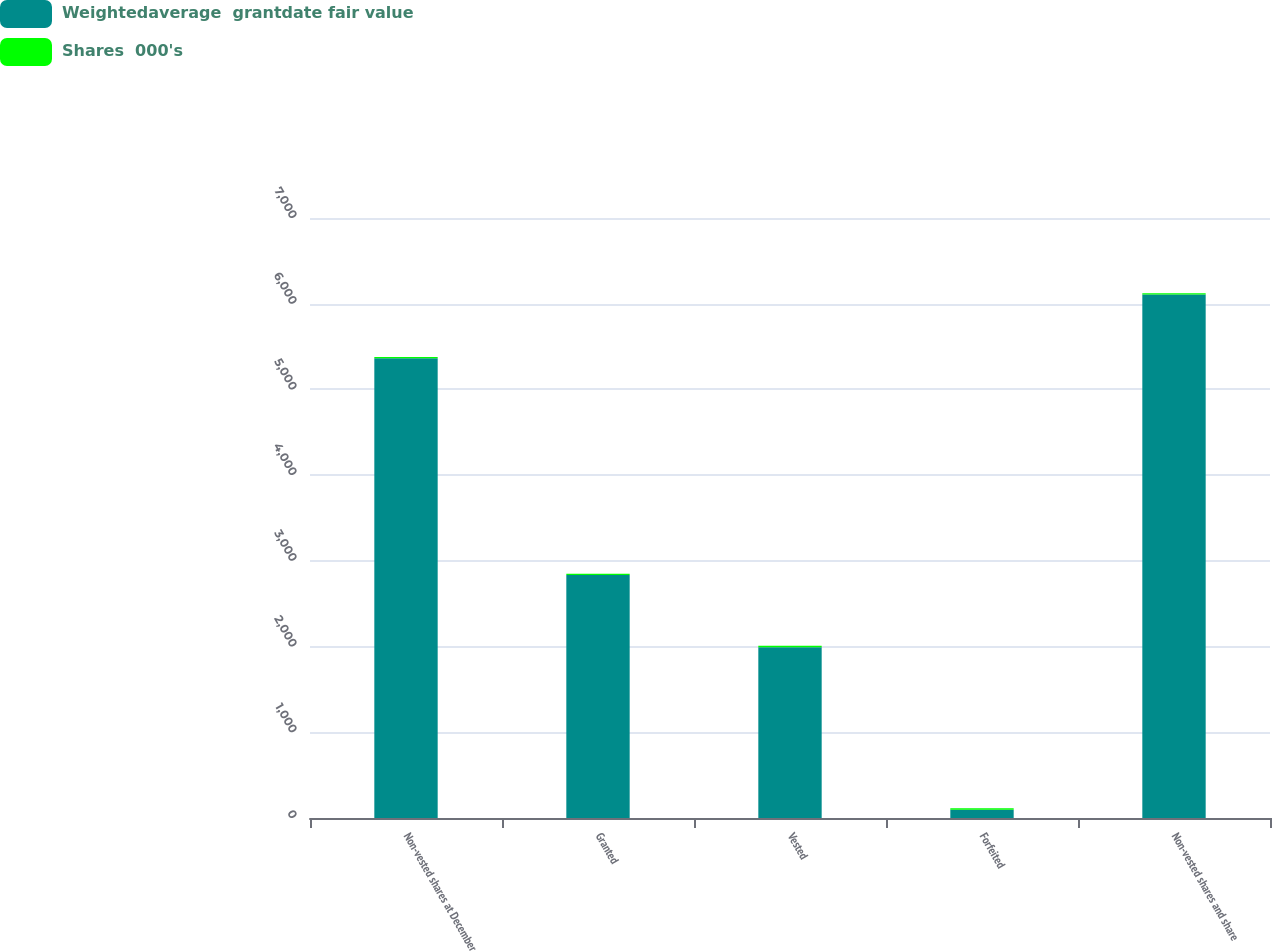<chart> <loc_0><loc_0><loc_500><loc_500><stacked_bar_chart><ecel><fcel>Non-vested shares at December<fcel>Granted<fcel>Vested<fcel>Forfeited<fcel>Non-vested shares and share<nl><fcel>Weightedaverage  grantdate fair value<fcel>5363<fcel>2835<fcel>1993<fcel>97<fcel>6108<nl><fcel>Shares  000's<fcel>15.97<fcel>13.73<fcel>17.08<fcel>15.41<fcel>14.58<nl></chart> 